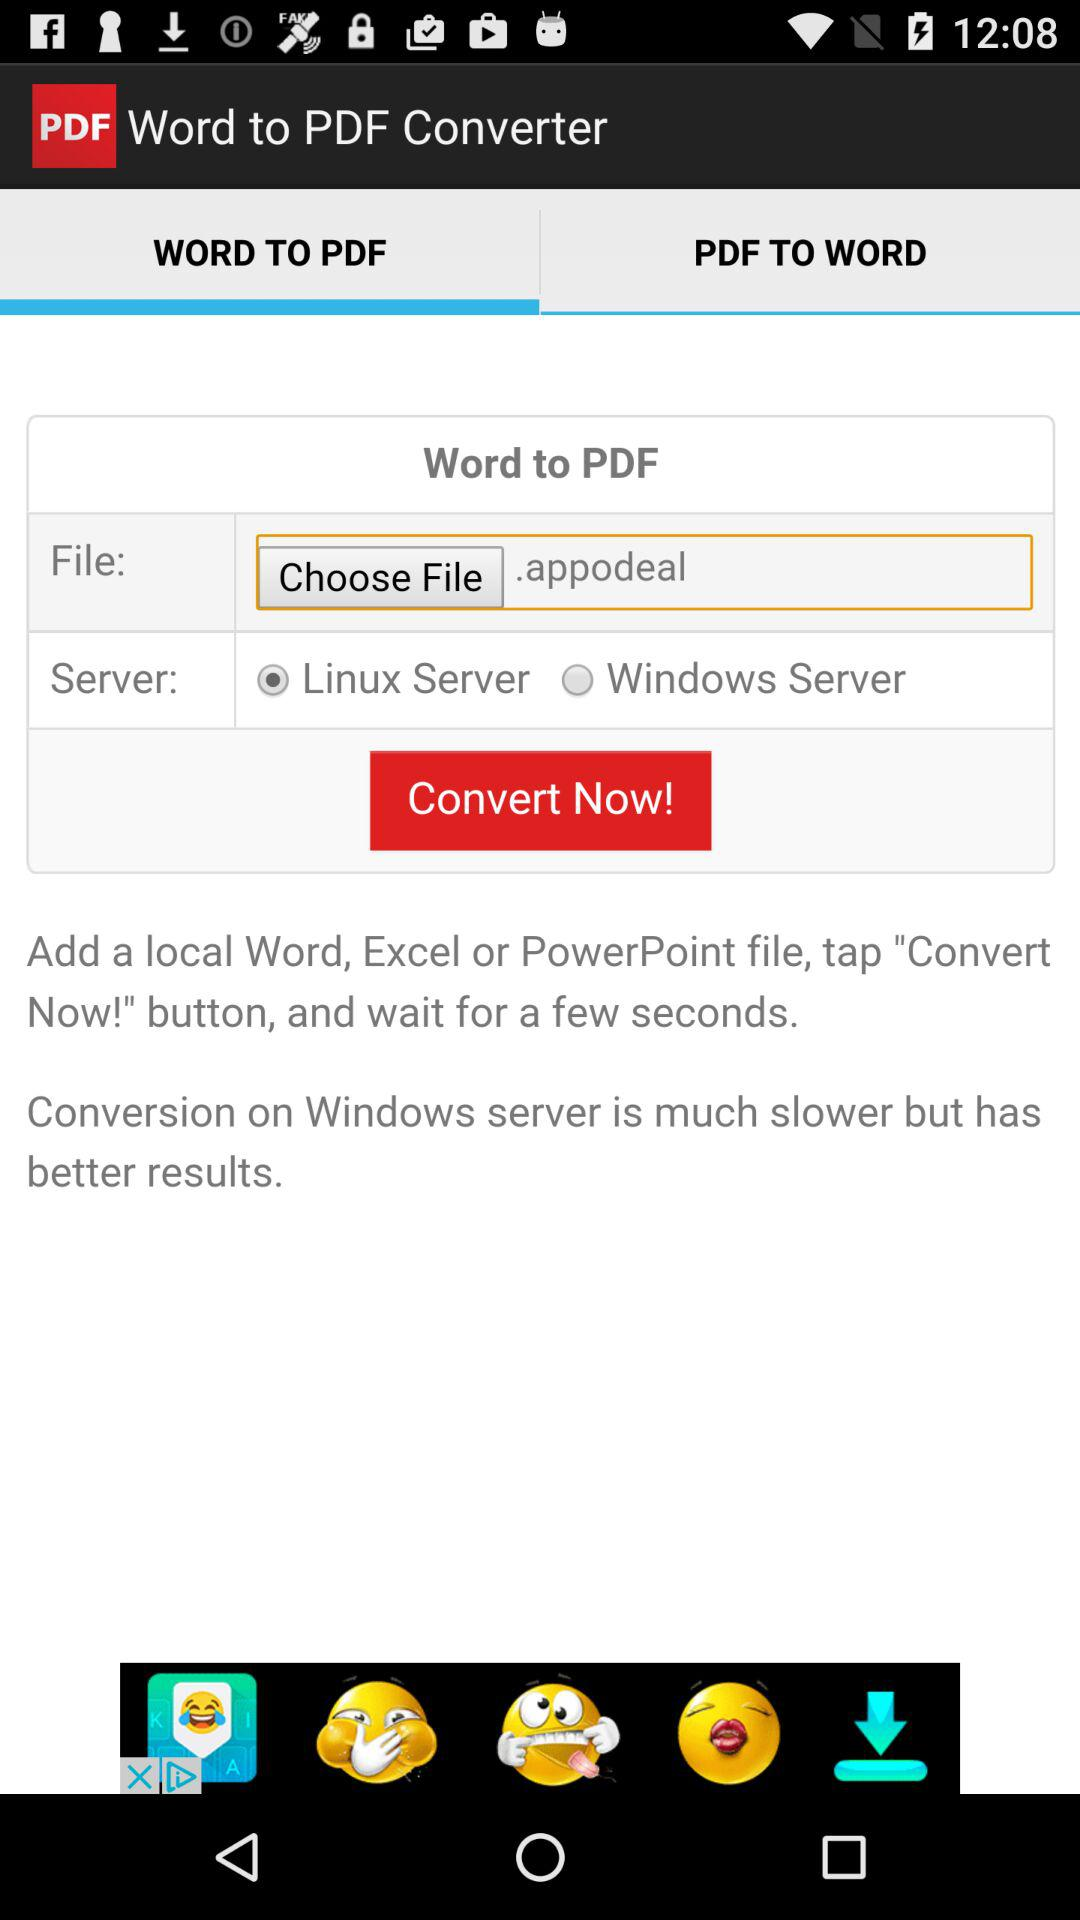Which tab is selected? The selected tab is "WORD TO PDF". 